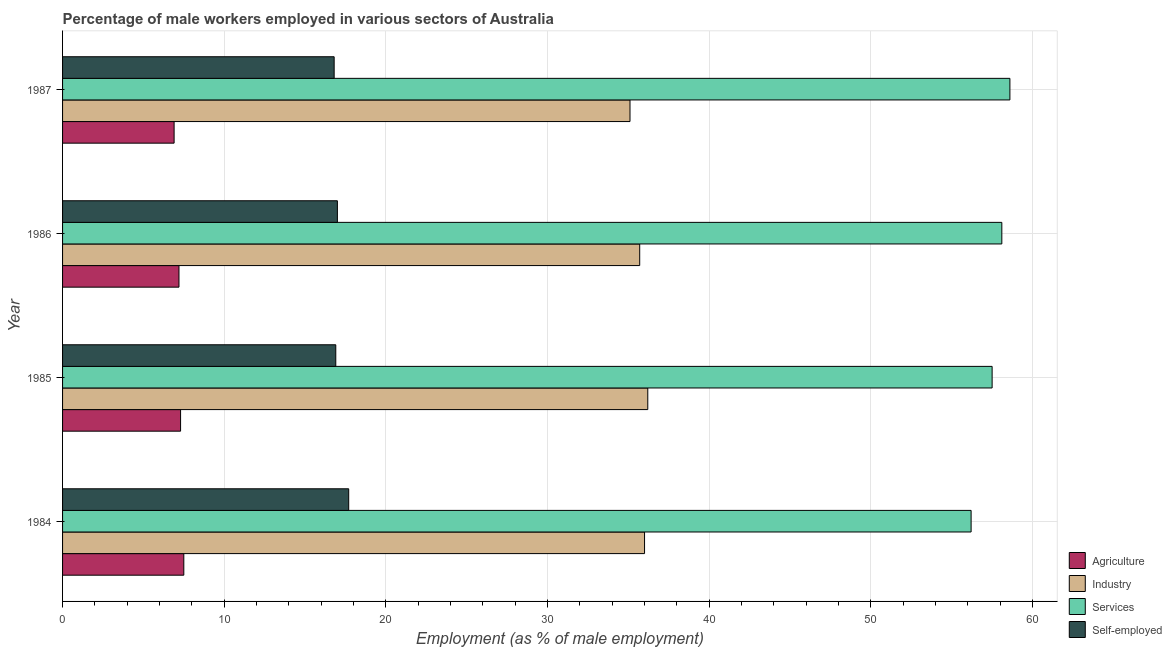How many groups of bars are there?
Keep it short and to the point. 4. Are the number of bars per tick equal to the number of legend labels?
Your answer should be very brief. Yes. How many bars are there on the 4th tick from the top?
Offer a terse response. 4. How many bars are there on the 3rd tick from the bottom?
Your response must be concise. 4. In how many cases, is the number of bars for a given year not equal to the number of legend labels?
Offer a terse response. 0. What is the percentage of male workers in services in 1985?
Your answer should be very brief. 57.5. Across all years, what is the maximum percentage of self employed male workers?
Make the answer very short. 17.7. Across all years, what is the minimum percentage of male workers in industry?
Provide a succinct answer. 35.1. What is the total percentage of self employed male workers in the graph?
Your answer should be very brief. 68.4. What is the difference between the percentage of male workers in agriculture in 1985 and the percentage of self employed male workers in 1984?
Your answer should be very brief. -10.4. In the year 1985, what is the difference between the percentage of male workers in services and percentage of male workers in agriculture?
Your response must be concise. 50.2. Is the percentage of male workers in agriculture in 1984 less than that in 1987?
Make the answer very short. No. Is the difference between the percentage of male workers in industry in 1985 and 1987 greater than the difference between the percentage of male workers in services in 1985 and 1987?
Your answer should be very brief. Yes. What is the difference between the highest and the second highest percentage of male workers in industry?
Ensure brevity in your answer.  0.2. What is the difference between the highest and the lowest percentage of male workers in industry?
Your response must be concise. 1.1. In how many years, is the percentage of male workers in industry greater than the average percentage of male workers in industry taken over all years?
Ensure brevity in your answer.  2. Is it the case that in every year, the sum of the percentage of male workers in industry and percentage of male workers in agriculture is greater than the sum of percentage of self employed male workers and percentage of male workers in services?
Make the answer very short. No. What does the 4th bar from the top in 1987 represents?
Give a very brief answer. Agriculture. What does the 2nd bar from the bottom in 1986 represents?
Ensure brevity in your answer.  Industry. How many bars are there?
Your answer should be compact. 16. Are all the bars in the graph horizontal?
Provide a short and direct response. Yes. Are the values on the major ticks of X-axis written in scientific E-notation?
Offer a very short reply. No. Does the graph contain grids?
Keep it short and to the point. Yes. What is the title of the graph?
Provide a succinct answer. Percentage of male workers employed in various sectors of Australia. Does "Structural Policies" appear as one of the legend labels in the graph?
Your response must be concise. No. What is the label or title of the X-axis?
Your answer should be very brief. Employment (as % of male employment). What is the label or title of the Y-axis?
Make the answer very short. Year. What is the Employment (as % of male employment) in Services in 1984?
Make the answer very short. 56.2. What is the Employment (as % of male employment) of Self-employed in 1984?
Your answer should be very brief. 17.7. What is the Employment (as % of male employment) of Agriculture in 1985?
Offer a very short reply. 7.3. What is the Employment (as % of male employment) in Industry in 1985?
Give a very brief answer. 36.2. What is the Employment (as % of male employment) in Services in 1985?
Provide a succinct answer. 57.5. What is the Employment (as % of male employment) in Self-employed in 1985?
Give a very brief answer. 16.9. What is the Employment (as % of male employment) of Agriculture in 1986?
Your answer should be very brief. 7.2. What is the Employment (as % of male employment) in Industry in 1986?
Ensure brevity in your answer.  35.7. What is the Employment (as % of male employment) in Services in 1986?
Make the answer very short. 58.1. What is the Employment (as % of male employment) of Agriculture in 1987?
Ensure brevity in your answer.  6.9. What is the Employment (as % of male employment) of Industry in 1987?
Ensure brevity in your answer.  35.1. What is the Employment (as % of male employment) in Services in 1987?
Your answer should be very brief. 58.6. What is the Employment (as % of male employment) in Self-employed in 1987?
Provide a short and direct response. 16.8. Across all years, what is the maximum Employment (as % of male employment) of Agriculture?
Make the answer very short. 7.5. Across all years, what is the maximum Employment (as % of male employment) of Industry?
Offer a very short reply. 36.2. Across all years, what is the maximum Employment (as % of male employment) of Services?
Make the answer very short. 58.6. Across all years, what is the maximum Employment (as % of male employment) in Self-employed?
Make the answer very short. 17.7. Across all years, what is the minimum Employment (as % of male employment) of Agriculture?
Offer a very short reply. 6.9. Across all years, what is the minimum Employment (as % of male employment) of Industry?
Offer a very short reply. 35.1. Across all years, what is the minimum Employment (as % of male employment) in Services?
Your response must be concise. 56.2. Across all years, what is the minimum Employment (as % of male employment) of Self-employed?
Provide a short and direct response. 16.8. What is the total Employment (as % of male employment) of Agriculture in the graph?
Provide a short and direct response. 28.9. What is the total Employment (as % of male employment) in Industry in the graph?
Offer a very short reply. 143. What is the total Employment (as % of male employment) of Services in the graph?
Provide a succinct answer. 230.4. What is the total Employment (as % of male employment) of Self-employed in the graph?
Your answer should be very brief. 68.4. What is the difference between the Employment (as % of male employment) of Agriculture in 1984 and that in 1985?
Give a very brief answer. 0.2. What is the difference between the Employment (as % of male employment) in Services in 1984 and that in 1985?
Provide a succinct answer. -1.3. What is the difference between the Employment (as % of male employment) of Industry in 1984 and that in 1986?
Give a very brief answer. 0.3. What is the difference between the Employment (as % of male employment) in Services in 1984 and that in 1986?
Give a very brief answer. -1.9. What is the difference between the Employment (as % of male employment) of Self-employed in 1984 and that in 1986?
Ensure brevity in your answer.  0.7. What is the difference between the Employment (as % of male employment) in Agriculture in 1984 and that in 1987?
Offer a very short reply. 0.6. What is the difference between the Employment (as % of male employment) of Industry in 1984 and that in 1987?
Make the answer very short. 0.9. What is the difference between the Employment (as % of male employment) of Agriculture in 1985 and that in 1986?
Keep it short and to the point. 0.1. What is the difference between the Employment (as % of male employment) in Industry in 1985 and that in 1986?
Keep it short and to the point. 0.5. What is the difference between the Employment (as % of male employment) in Services in 1985 and that in 1986?
Ensure brevity in your answer.  -0.6. What is the difference between the Employment (as % of male employment) in Self-employed in 1985 and that in 1986?
Offer a terse response. -0.1. What is the difference between the Employment (as % of male employment) in Agriculture in 1985 and that in 1987?
Your answer should be compact. 0.4. What is the difference between the Employment (as % of male employment) of Industry in 1985 and that in 1987?
Your answer should be compact. 1.1. What is the difference between the Employment (as % of male employment) of Services in 1985 and that in 1987?
Provide a short and direct response. -1.1. What is the difference between the Employment (as % of male employment) of Industry in 1986 and that in 1987?
Your answer should be very brief. 0.6. What is the difference between the Employment (as % of male employment) in Self-employed in 1986 and that in 1987?
Offer a very short reply. 0.2. What is the difference between the Employment (as % of male employment) in Agriculture in 1984 and the Employment (as % of male employment) in Industry in 1985?
Your response must be concise. -28.7. What is the difference between the Employment (as % of male employment) in Agriculture in 1984 and the Employment (as % of male employment) in Services in 1985?
Offer a terse response. -50. What is the difference between the Employment (as % of male employment) of Agriculture in 1984 and the Employment (as % of male employment) of Self-employed in 1985?
Offer a very short reply. -9.4. What is the difference between the Employment (as % of male employment) in Industry in 1984 and the Employment (as % of male employment) in Services in 1985?
Give a very brief answer. -21.5. What is the difference between the Employment (as % of male employment) of Services in 1984 and the Employment (as % of male employment) of Self-employed in 1985?
Your answer should be compact. 39.3. What is the difference between the Employment (as % of male employment) of Agriculture in 1984 and the Employment (as % of male employment) of Industry in 1986?
Your answer should be very brief. -28.2. What is the difference between the Employment (as % of male employment) in Agriculture in 1984 and the Employment (as % of male employment) in Services in 1986?
Offer a very short reply. -50.6. What is the difference between the Employment (as % of male employment) in Industry in 1984 and the Employment (as % of male employment) in Services in 1986?
Offer a very short reply. -22.1. What is the difference between the Employment (as % of male employment) in Services in 1984 and the Employment (as % of male employment) in Self-employed in 1986?
Offer a very short reply. 39.2. What is the difference between the Employment (as % of male employment) in Agriculture in 1984 and the Employment (as % of male employment) in Industry in 1987?
Your answer should be compact. -27.6. What is the difference between the Employment (as % of male employment) of Agriculture in 1984 and the Employment (as % of male employment) of Services in 1987?
Ensure brevity in your answer.  -51.1. What is the difference between the Employment (as % of male employment) in Agriculture in 1984 and the Employment (as % of male employment) in Self-employed in 1987?
Your answer should be very brief. -9.3. What is the difference between the Employment (as % of male employment) in Industry in 1984 and the Employment (as % of male employment) in Services in 1987?
Your response must be concise. -22.6. What is the difference between the Employment (as % of male employment) of Industry in 1984 and the Employment (as % of male employment) of Self-employed in 1987?
Your answer should be very brief. 19.2. What is the difference between the Employment (as % of male employment) in Services in 1984 and the Employment (as % of male employment) in Self-employed in 1987?
Ensure brevity in your answer.  39.4. What is the difference between the Employment (as % of male employment) of Agriculture in 1985 and the Employment (as % of male employment) of Industry in 1986?
Provide a succinct answer. -28.4. What is the difference between the Employment (as % of male employment) in Agriculture in 1985 and the Employment (as % of male employment) in Services in 1986?
Your answer should be compact. -50.8. What is the difference between the Employment (as % of male employment) of Agriculture in 1985 and the Employment (as % of male employment) of Self-employed in 1986?
Make the answer very short. -9.7. What is the difference between the Employment (as % of male employment) in Industry in 1985 and the Employment (as % of male employment) in Services in 1986?
Your response must be concise. -21.9. What is the difference between the Employment (as % of male employment) in Services in 1985 and the Employment (as % of male employment) in Self-employed in 1986?
Your answer should be very brief. 40.5. What is the difference between the Employment (as % of male employment) of Agriculture in 1985 and the Employment (as % of male employment) of Industry in 1987?
Your answer should be compact. -27.8. What is the difference between the Employment (as % of male employment) of Agriculture in 1985 and the Employment (as % of male employment) of Services in 1987?
Ensure brevity in your answer.  -51.3. What is the difference between the Employment (as % of male employment) of Agriculture in 1985 and the Employment (as % of male employment) of Self-employed in 1987?
Offer a very short reply. -9.5. What is the difference between the Employment (as % of male employment) of Industry in 1985 and the Employment (as % of male employment) of Services in 1987?
Make the answer very short. -22.4. What is the difference between the Employment (as % of male employment) in Industry in 1985 and the Employment (as % of male employment) in Self-employed in 1987?
Offer a terse response. 19.4. What is the difference between the Employment (as % of male employment) of Services in 1985 and the Employment (as % of male employment) of Self-employed in 1987?
Provide a succinct answer. 40.7. What is the difference between the Employment (as % of male employment) of Agriculture in 1986 and the Employment (as % of male employment) of Industry in 1987?
Keep it short and to the point. -27.9. What is the difference between the Employment (as % of male employment) of Agriculture in 1986 and the Employment (as % of male employment) of Services in 1987?
Ensure brevity in your answer.  -51.4. What is the difference between the Employment (as % of male employment) in Industry in 1986 and the Employment (as % of male employment) in Services in 1987?
Ensure brevity in your answer.  -22.9. What is the difference between the Employment (as % of male employment) in Industry in 1986 and the Employment (as % of male employment) in Self-employed in 1987?
Keep it short and to the point. 18.9. What is the difference between the Employment (as % of male employment) in Services in 1986 and the Employment (as % of male employment) in Self-employed in 1987?
Offer a very short reply. 41.3. What is the average Employment (as % of male employment) in Agriculture per year?
Offer a terse response. 7.22. What is the average Employment (as % of male employment) in Industry per year?
Offer a very short reply. 35.75. What is the average Employment (as % of male employment) in Services per year?
Your answer should be compact. 57.6. What is the average Employment (as % of male employment) in Self-employed per year?
Your answer should be compact. 17.1. In the year 1984, what is the difference between the Employment (as % of male employment) in Agriculture and Employment (as % of male employment) in Industry?
Give a very brief answer. -28.5. In the year 1984, what is the difference between the Employment (as % of male employment) of Agriculture and Employment (as % of male employment) of Services?
Ensure brevity in your answer.  -48.7. In the year 1984, what is the difference between the Employment (as % of male employment) in Industry and Employment (as % of male employment) in Services?
Ensure brevity in your answer.  -20.2. In the year 1984, what is the difference between the Employment (as % of male employment) in Services and Employment (as % of male employment) in Self-employed?
Your answer should be compact. 38.5. In the year 1985, what is the difference between the Employment (as % of male employment) in Agriculture and Employment (as % of male employment) in Industry?
Your answer should be compact. -28.9. In the year 1985, what is the difference between the Employment (as % of male employment) of Agriculture and Employment (as % of male employment) of Services?
Provide a short and direct response. -50.2. In the year 1985, what is the difference between the Employment (as % of male employment) in Industry and Employment (as % of male employment) in Services?
Your response must be concise. -21.3. In the year 1985, what is the difference between the Employment (as % of male employment) of Industry and Employment (as % of male employment) of Self-employed?
Ensure brevity in your answer.  19.3. In the year 1985, what is the difference between the Employment (as % of male employment) of Services and Employment (as % of male employment) of Self-employed?
Your answer should be very brief. 40.6. In the year 1986, what is the difference between the Employment (as % of male employment) of Agriculture and Employment (as % of male employment) of Industry?
Your answer should be very brief. -28.5. In the year 1986, what is the difference between the Employment (as % of male employment) in Agriculture and Employment (as % of male employment) in Services?
Ensure brevity in your answer.  -50.9. In the year 1986, what is the difference between the Employment (as % of male employment) of Industry and Employment (as % of male employment) of Services?
Give a very brief answer. -22.4. In the year 1986, what is the difference between the Employment (as % of male employment) of Industry and Employment (as % of male employment) of Self-employed?
Provide a short and direct response. 18.7. In the year 1986, what is the difference between the Employment (as % of male employment) of Services and Employment (as % of male employment) of Self-employed?
Offer a very short reply. 41.1. In the year 1987, what is the difference between the Employment (as % of male employment) of Agriculture and Employment (as % of male employment) of Industry?
Provide a succinct answer. -28.2. In the year 1987, what is the difference between the Employment (as % of male employment) of Agriculture and Employment (as % of male employment) of Services?
Your answer should be compact. -51.7. In the year 1987, what is the difference between the Employment (as % of male employment) of Industry and Employment (as % of male employment) of Services?
Provide a short and direct response. -23.5. In the year 1987, what is the difference between the Employment (as % of male employment) of Industry and Employment (as % of male employment) of Self-employed?
Your answer should be very brief. 18.3. In the year 1987, what is the difference between the Employment (as % of male employment) of Services and Employment (as % of male employment) of Self-employed?
Your answer should be very brief. 41.8. What is the ratio of the Employment (as % of male employment) in Agriculture in 1984 to that in 1985?
Your answer should be very brief. 1.03. What is the ratio of the Employment (as % of male employment) in Industry in 1984 to that in 1985?
Ensure brevity in your answer.  0.99. What is the ratio of the Employment (as % of male employment) in Services in 1984 to that in 1985?
Offer a terse response. 0.98. What is the ratio of the Employment (as % of male employment) in Self-employed in 1984 to that in 1985?
Ensure brevity in your answer.  1.05. What is the ratio of the Employment (as % of male employment) of Agriculture in 1984 to that in 1986?
Offer a terse response. 1.04. What is the ratio of the Employment (as % of male employment) of Industry in 1984 to that in 1986?
Make the answer very short. 1.01. What is the ratio of the Employment (as % of male employment) in Services in 1984 to that in 1986?
Give a very brief answer. 0.97. What is the ratio of the Employment (as % of male employment) of Self-employed in 1984 to that in 1986?
Provide a short and direct response. 1.04. What is the ratio of the Employment (as % of male employment) in Agriculture in 1984 to that in 1987?
Offer a very short reply. 1.09. What is the ratio of the Employment (as % of male employment) of Industry in 1984 to that in 1987?
Offer a terse response. 1.03. What is the ratio of the Employment (as % of male employment) of Services in 1984 to that in 1987?
Ensure brevity in your answer.  0.96. What is the ratio of the Employment (as % of male employment) of Self-employed in 1984 to that in 1987?
Ensure brevity in your answer.  1.05. What is the ratio of the Employment (as % of male employment) of Agriculture in 1985 to that in 1986?
Provide a succinct answer. 1.01. What is the ratio of the Employment (as % of male employment) in Industry in 1985 to that in 1986?
Your response must be concise. 1.01. What is the ratio of the Employment (as % of male employment) of Services in 1985 to that in 1986?
Give a very brief answer. 0.99. What is the ratio of the Employment (as % of male employment) of Agriculture in 1985 to that in 1987?
Provide a succinct answer. 1.06. What is the ratio of the Employment (as % of male employment) in Industry in 1985 to that in 1987?
Provide a short and direct response. 1.03. What is the ratio of the Employment (as % of male employment) in Services in 1985 to that in 1987?
Make the answer very short. 0.98. What is the ratio of the Employment (as % of male employment) of Self-employed in 1985 to that in 1987?
Offer a very short reply. 1.01. What is the ratio of the Employment (as % of male employment) of Agriculture in 1986 to that in 1987?
Offer a very short reply. 1.04. What is the ratio of the Employment (as % of male employment) in Industry in 1986 to that in 1987?
Give a very brief answer. 1.02. What is the ratio of the Employment (as % of male employment) in Services in 1986 to that in 1987?
Make the answer very short. 0.99. What is the ratio of the Employment (as % of male employment) of Self-employed in 1986 to that in 1987?
Your response must be concise. 1.01. What is the difference between the highest and the second highest Employment (as % of male employment) in Self-employed?
Ensure brevity in your answer.  0.7. What is the difference between the highest and the lowest Employment (as % of male employment) in Industry?
Offer a very short reply. 1.1. 